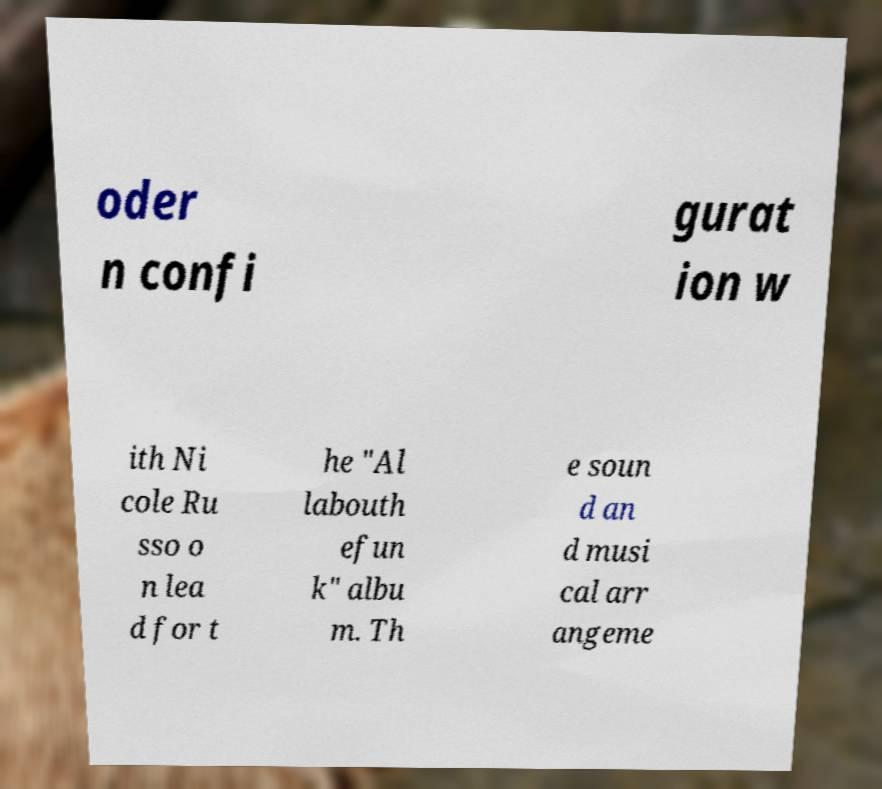Can you accurately transcribe the text from the provided image for me? oder n confi gurat ion w ith Ni cole Ru sso o n lea d for t he "Al labouth efun k" albu m. Th e soun d an d musi cal arr angeme 